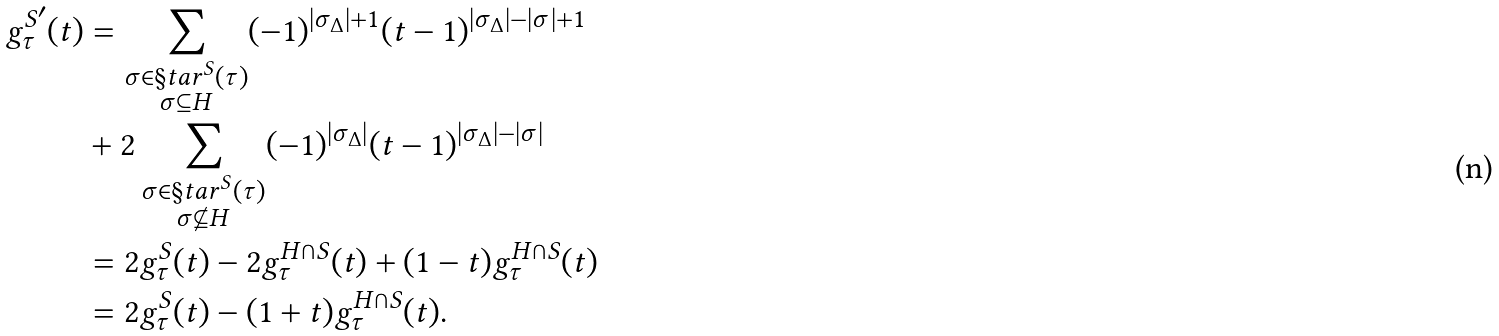Convert formula to latex. <formula><loc_0><loc_0><loc_500><loc_500>g ^ { S ^ { \prime } } _ { \tau } ( t ) & = \sum _ { \substack { \sigma \in \S t a r ^ { S } ( \tau ) \\ \sigma \subseteq H } } ( - 1 ) ^ { | \sigma _ { \Delta } | + 1 } ( t - 1 ) ^ { | \sigma _ { \Delta } | - | \sigma | + 1 } \\ & + 2 \sum _ { \substack { \sigma \in \S t a r ^ { S } ( \tau ) \\ \sigma \not \subseteq H } } ( - 1 ) ^ { | \sigma _ { \Delta } | } ( t - 1 ) ^ { | \sigma _ { \Delta } | - | \sigma | } \\ & = 2 g ^ { S } _ { \tau } ( t ) - 2 g ^ { H \cap S } _ { \tau } ( t ) + ( 1 - t ) g ^ { H \cap S } _ { \tau } ( t ) \\ & = 2 g ^ { S } _ { \tau } ( t ) - ( 1 + t ) g ^ { H \cap S } _ { \tau } ( t ) .</formula> 